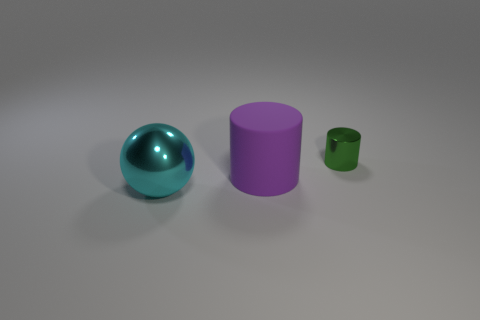Are there any other things that are the same shape as the tiny green metallic thing?
Make the answer very short. Yes. There is a metallic thing in front of the matte cylinder; is its color the same as the big cylinder?
Give a very brief answer. No. There is another object that is the same shape as the green shiny object; what is its size?
Offer a very short reply. Large. How many things have the same material as the ball?
Your response must be concise. 1. Is there a large sphere behind the metal thing that is left of the big object that is on the right side of the cyan ball?
Provide a short and direct response. No. What is the shape of the tiny metallic thing?
Your answer should be very brief. Cylinder. Are the large thing that is behind the cyan metal sphere and the object that is in front of the big purple matte object made of the same material?
Offer a terse response. No. What number of other big cylinders are the same color as the matte cylinder?
Ensure brevity in your answer.  0. What shape is the object that is to the left of the green cylinder and on the right side of the large cyan metal object?
Ensure brevity in your answer.  Cylinder. Is the number of large shiny spheres that are left of the large ball greater than the number of purple things that are behind the big purple cylinder?
Your answer should be very brief. No. 